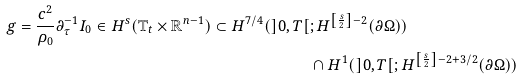<formula> <loc_0><loc_0><loc_500><loc_500>g = \frac { c ^ { 2 } } { \rho _ { 0 } } \partial _ { \tau } ^ { - 1 } I _ { 0 } \in H ^ { s } ( \mathbb { T } _ { t } \times \mathbb { R } ^ { n - 1 } ) \subset H ^ { 7 / 4 } ( ] 0 , T [ & ; H ^ { \left [ \frac { s } { 2 } \right ] - 2 } ( \partial \Omega ) ) \\ & \cap H ^ { 1 } ( ] 0 , T [ ; H ^ { \left [ \frac { s } { 2 } \right ] - 2 + 3 / 2 } ( \partial \Omega ) )</formula> 